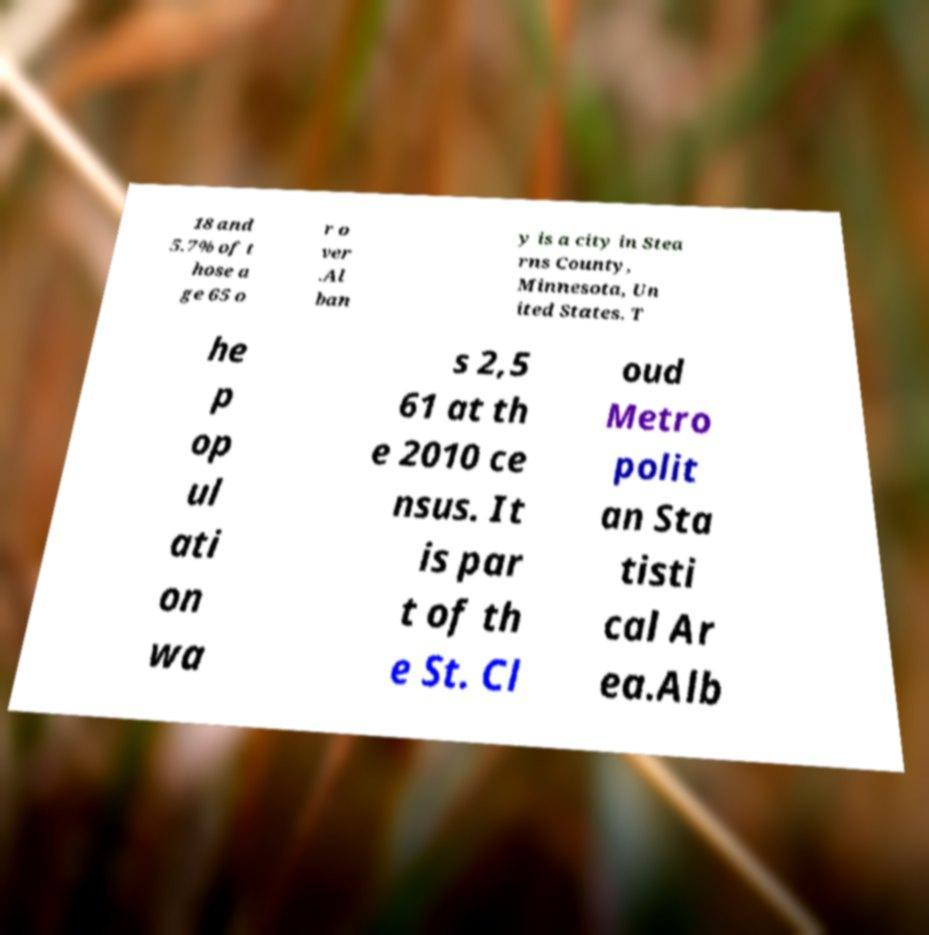What messages or text are displayed in this image? I need them in a readable, typed format. 18 and 5.7% of t hose a ge 65 o r o ver .Al ban y is a city in Stea rns County, Minnesota, Un ited States. T he p op ul ati on wa s 2,5 61 at th e 2010 ce nsus. It is par t of th e St. Cl oud Metro polit an Sta tisti cal Ar ea.Alb 